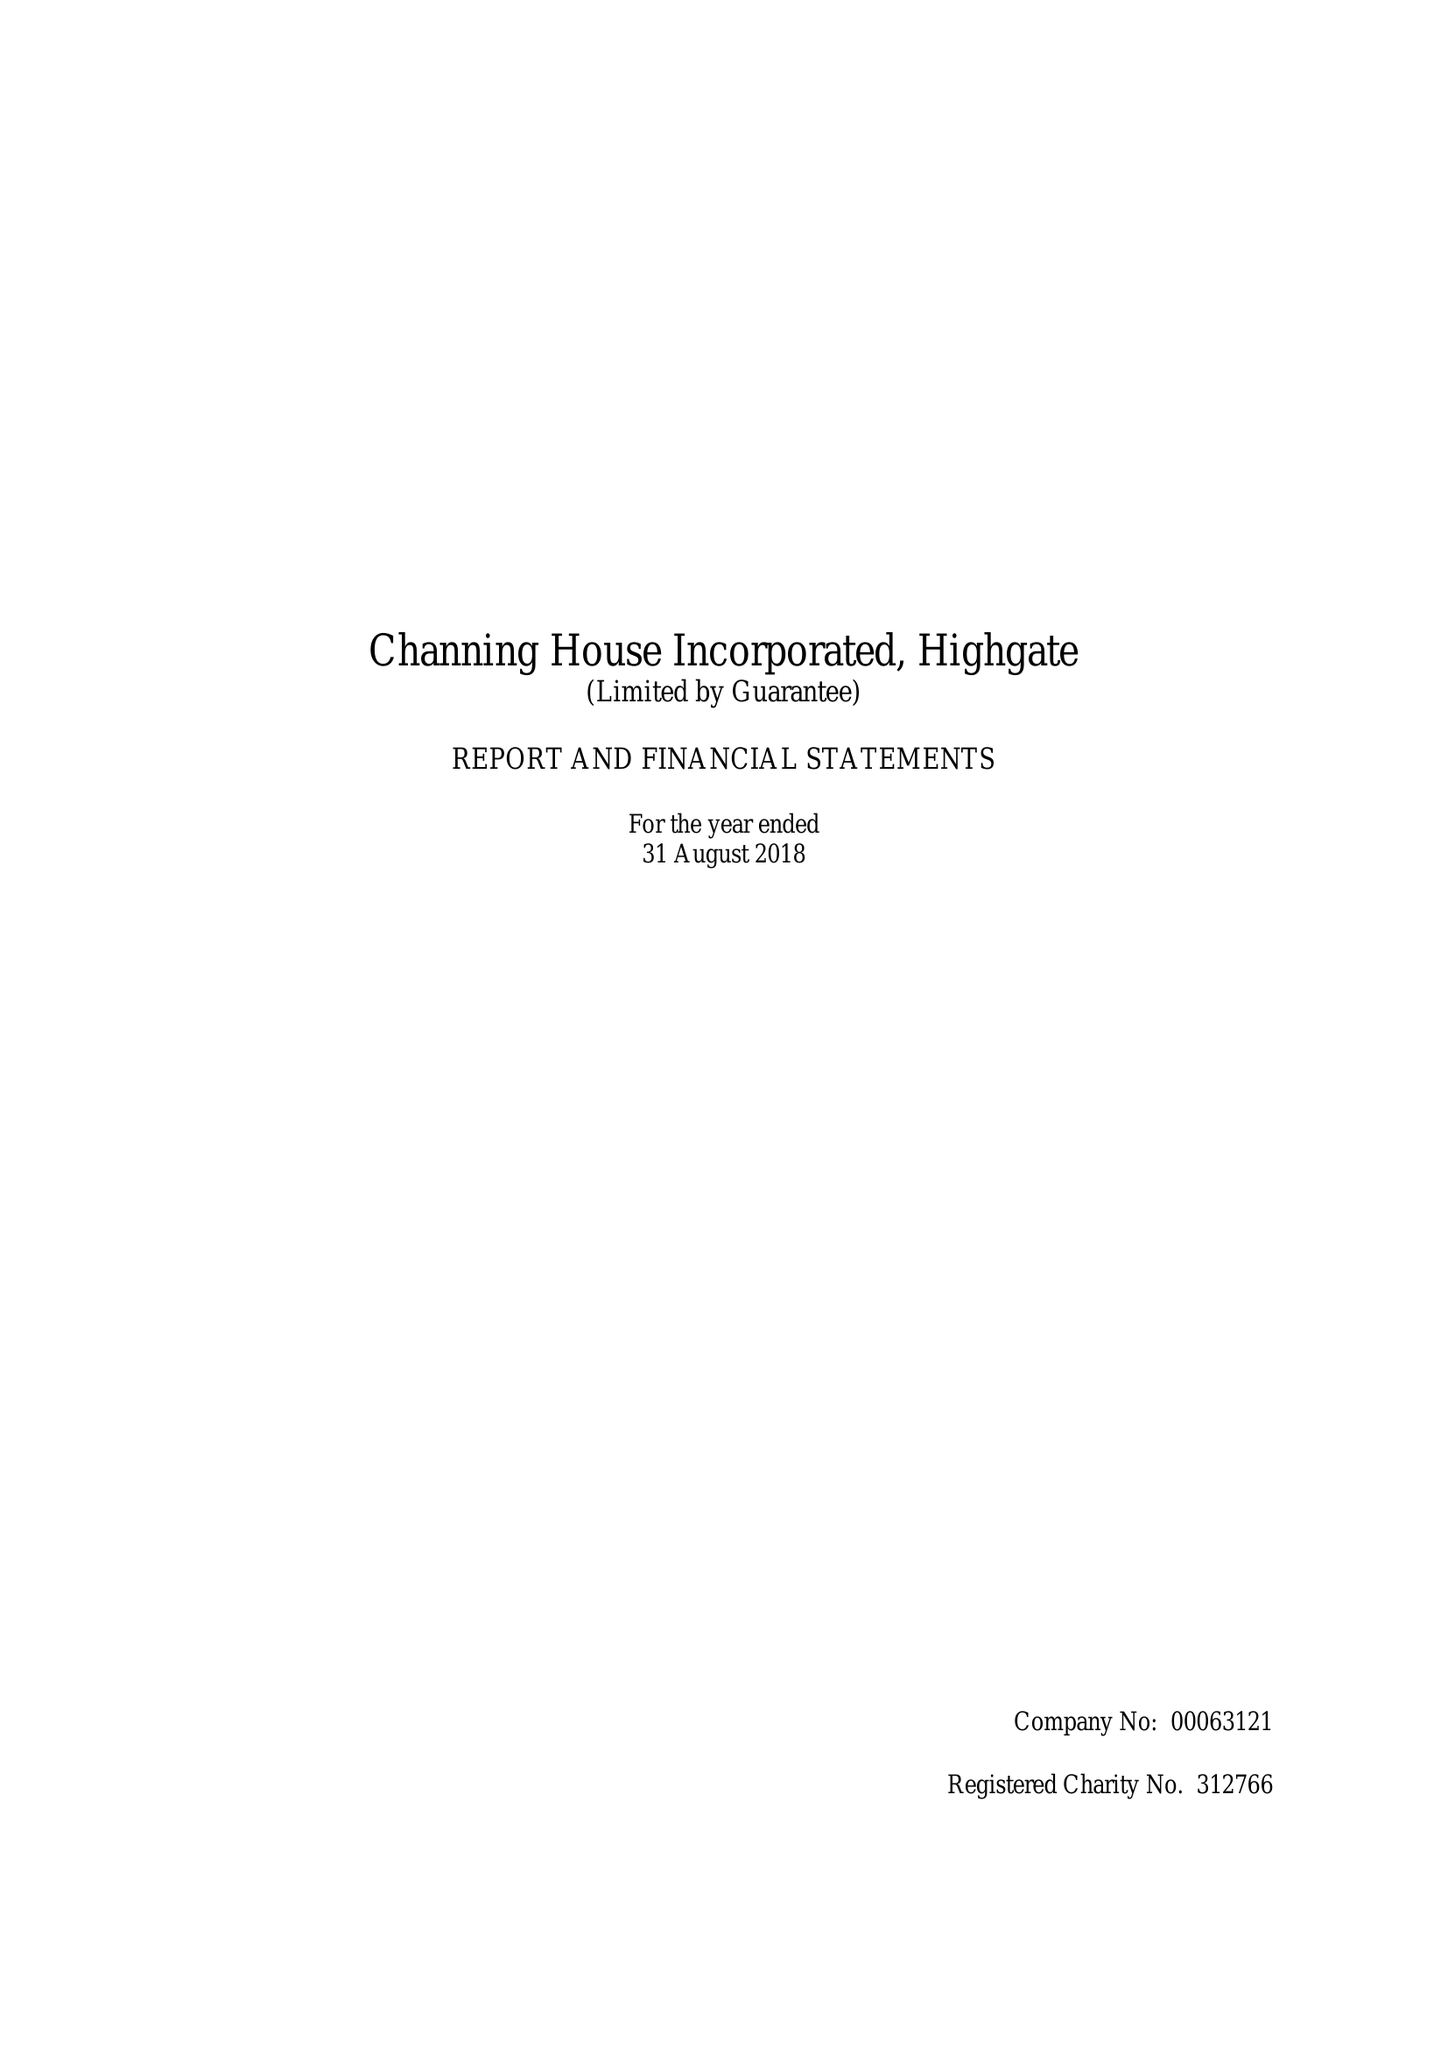What is the value for the charity_name?
Answer the question using a single word or phrase. Channing House Inc. 